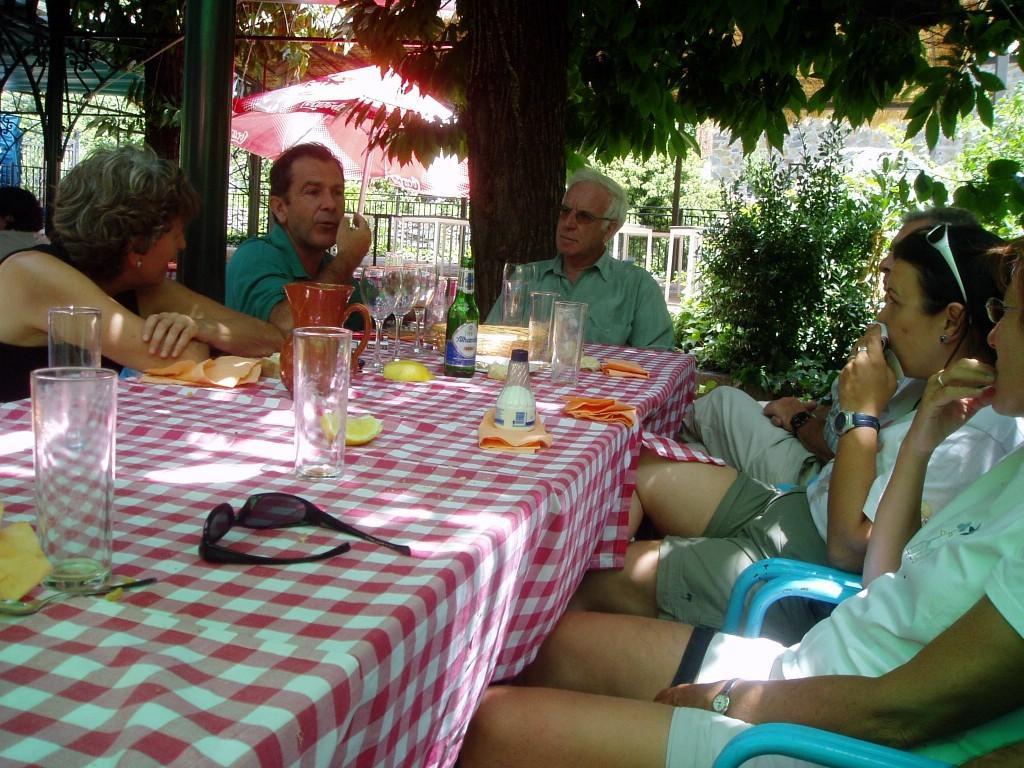Describe this image in one or two sentences. In this image there few people sitting on chairs at the table. A cloth spread on the table. On the table there are glasses, sunglasses, cloth, bottle, water mug and lemons. In the background there are trees, plants, railing and a table umbrella. 